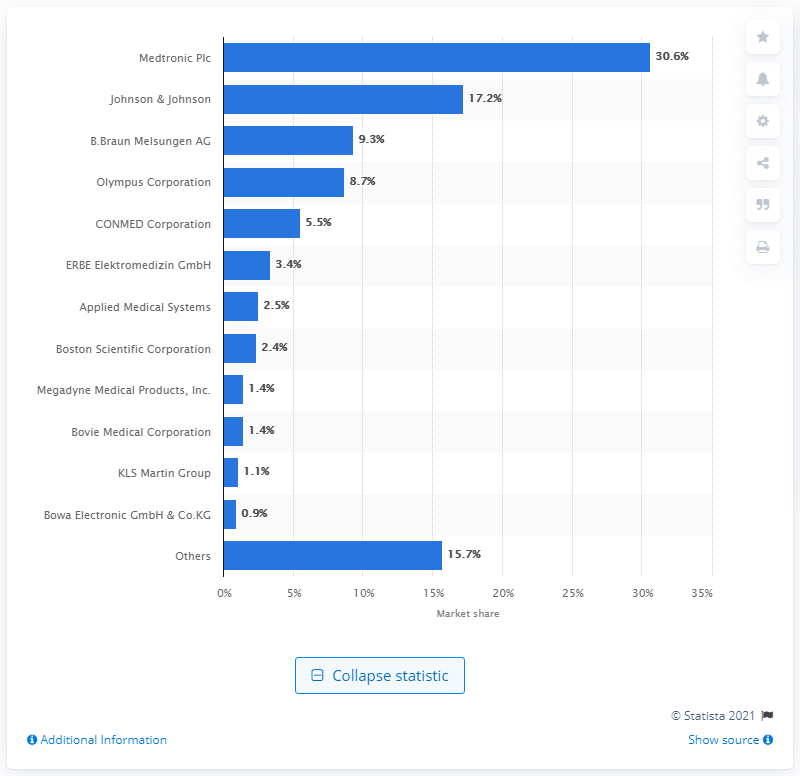Identify some key points in this picture. In 2016, Medtronic Plc. held a significant portion of the global market for electrosurgical devices, accounting for almost a third of the market share. 